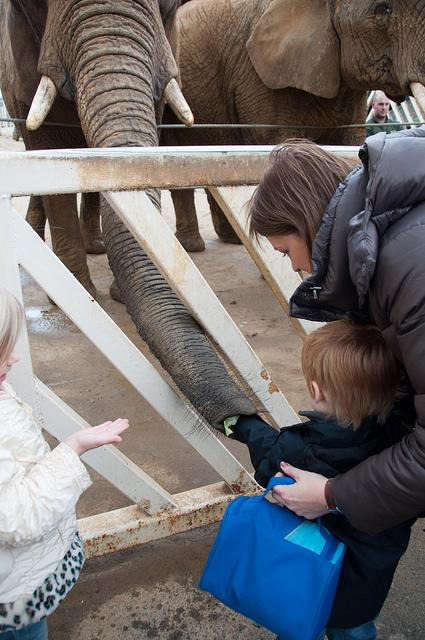Where are the elephants behind held?

Choices:
A) in circus
B) in park
C) in zoo
D) in prison in zoo 